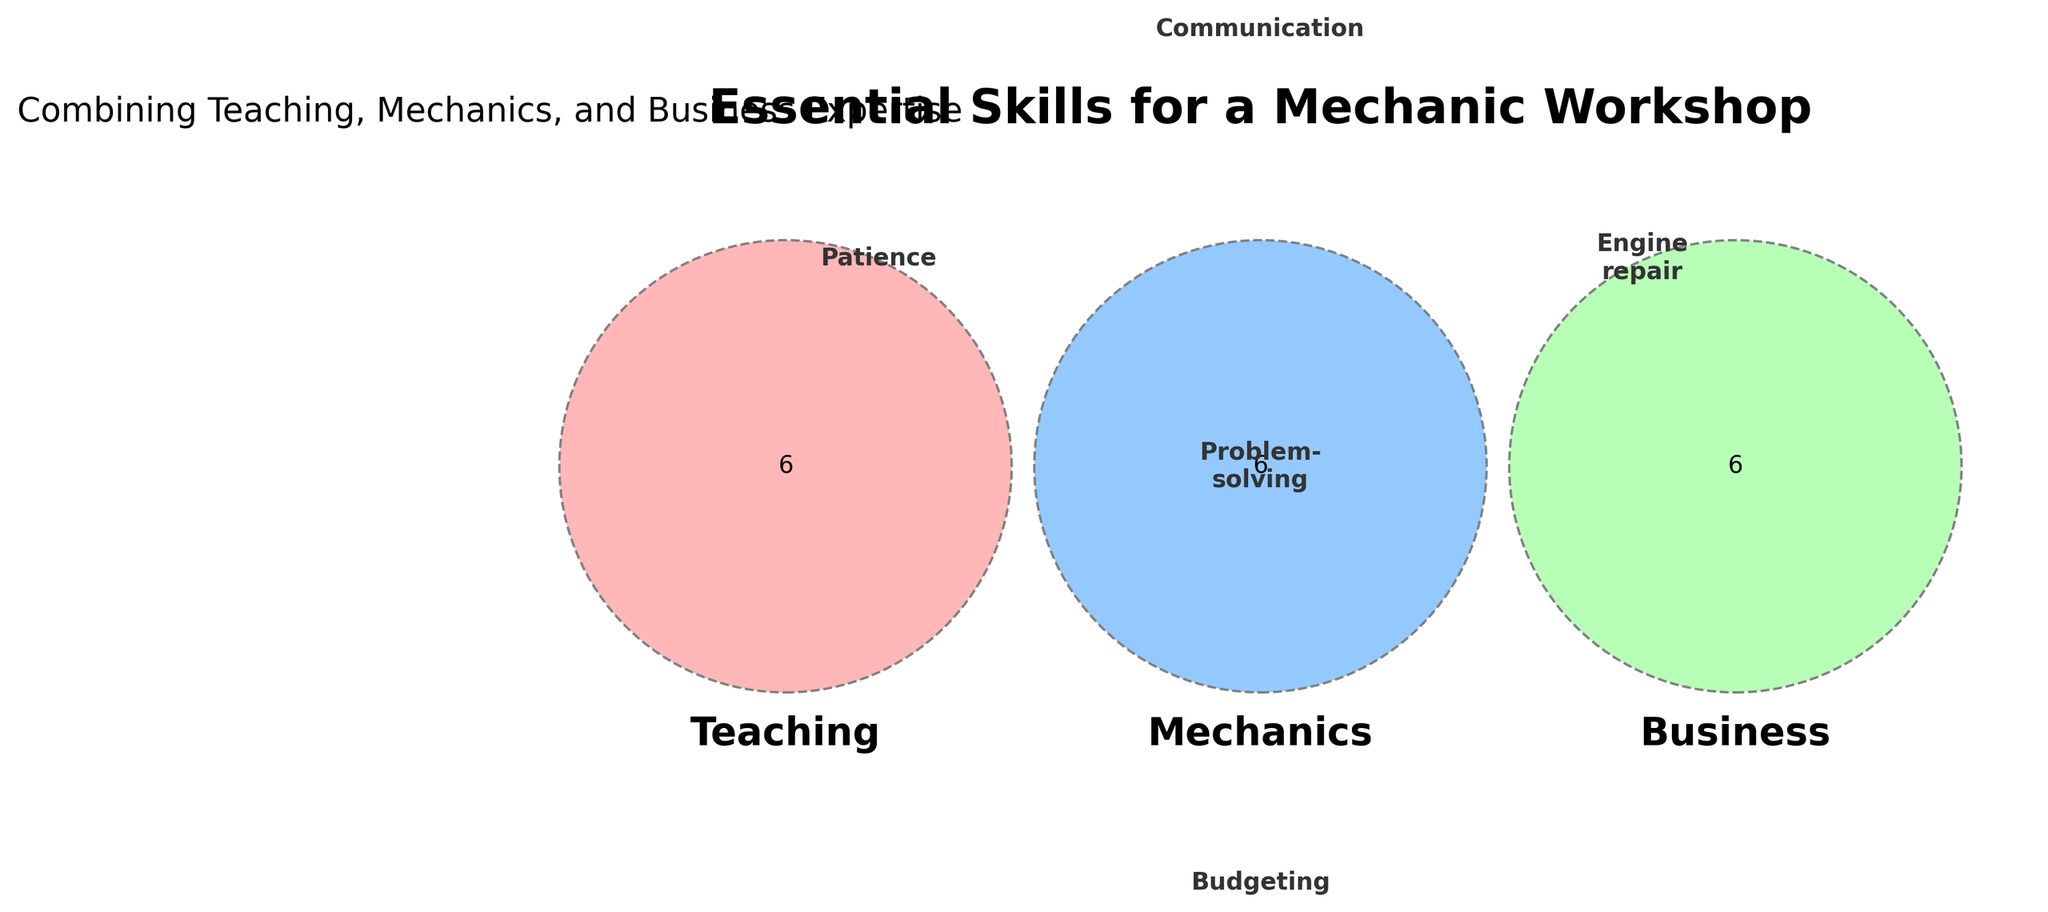What is the main purpose of this figure? The title of the figure, "Essential Skills for a Mechanic Workshop," indicates that it shows important skills needed for running a workshop, combining teaching, mechanics, and business expertise.
Answer: To show essential skills for a mechanic workshop Which skills are listed under both Mechanics and Business? By looking at the intersection of Mechanics and Business, we see "Inventory management," "Customer service," and "Pricing strategy."
Answer: Inventory management, Customer service, Pricing strategy How many skills are unique to Teaching? Teaching skills are unique if they do not overlap with Mechanics or Business. The skills listed in the Teaching section not intersecting with others are "Patience," "Lesson planning," "Classroom management," "Assessment," "Mentoring," and "Curriculum design."
Answer: Six Which skills are common to all three areas? The skills common to Teaching, Mechanics, and Business are listed in the center overlapping section of the Venn diagram, labeled "Communication," "Problem-solving," "Time management," "Leadership," and "Organization."
Answer: Communication, Problem-solving, Time management, Leadership, Organization What skill is shared between Teaching and Mechanics but not Business? By observing the intersection between Teaching and Mechanics, the shared skills excluding the Business section are "Mentoring" and "Electrical systems."
Answer: Mentoring, Electrical systems Which color represents Business skills? By noticing the colors in the Venn diagram, the green color (#99FF99) represents Business skills.
Answer: Green How does "Problem-solving" appear in the figure? "Problem-solving" is located in the overlapping central part of the Venn diagram, indicating it is relevant to Teaching, Mechanics, and Business.
Answer: Central overlap Which group has the fewest unique skills? By counting the number of unique skills for each section: Teaching (6), Mechanics (6), Business (6). All groups have the same number of unique skills.
Answer: All groups have the same List all skills that are related to Mechanics. The Mechanics section includes unique skills and those overlapping with other areas: "Engine repair," "Welding," "Diagnostics," "Brake systems," "Electrical systems," "Suspension," "Mentoring," "Communication," "Problem-solving," "Time management," "Leadership," and "Organization."
Answer: Engine repair, Welding, Diagnostics, Brake systems, Electrical systems, Suspension, Mentoring, Communication, Problem-solving, Time management, Leadership, Organization Which skills intersect between Teaching and Business but not Mechanics? By observing the overlap between Teaching and Business, excluding Mechanics, the skills are "Budgeting," "Marketing," "Accounting," "Customer service," "Pricing strategy," and "Adaptability."
Answer: Budgeting, Marketing, Accounting, Customer service, Pricing strategy, Adaptability 